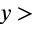<formula> <loc_0><loc_0><loc_500><loc_500>y ></formula> 